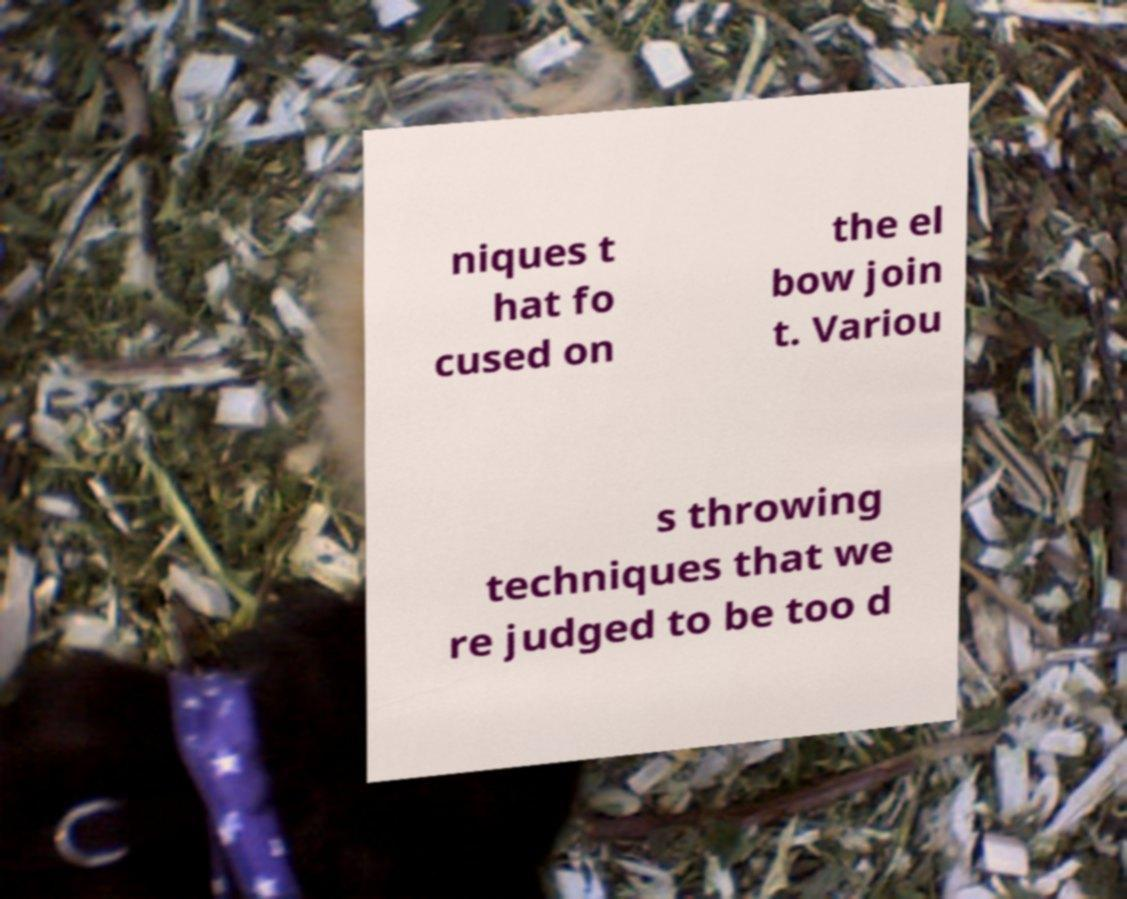Please read and relay the text visible in this image. What does it say? niques t hat fo cused on the el bow join t. Variou s throwing techniques that we re judged to be too d 